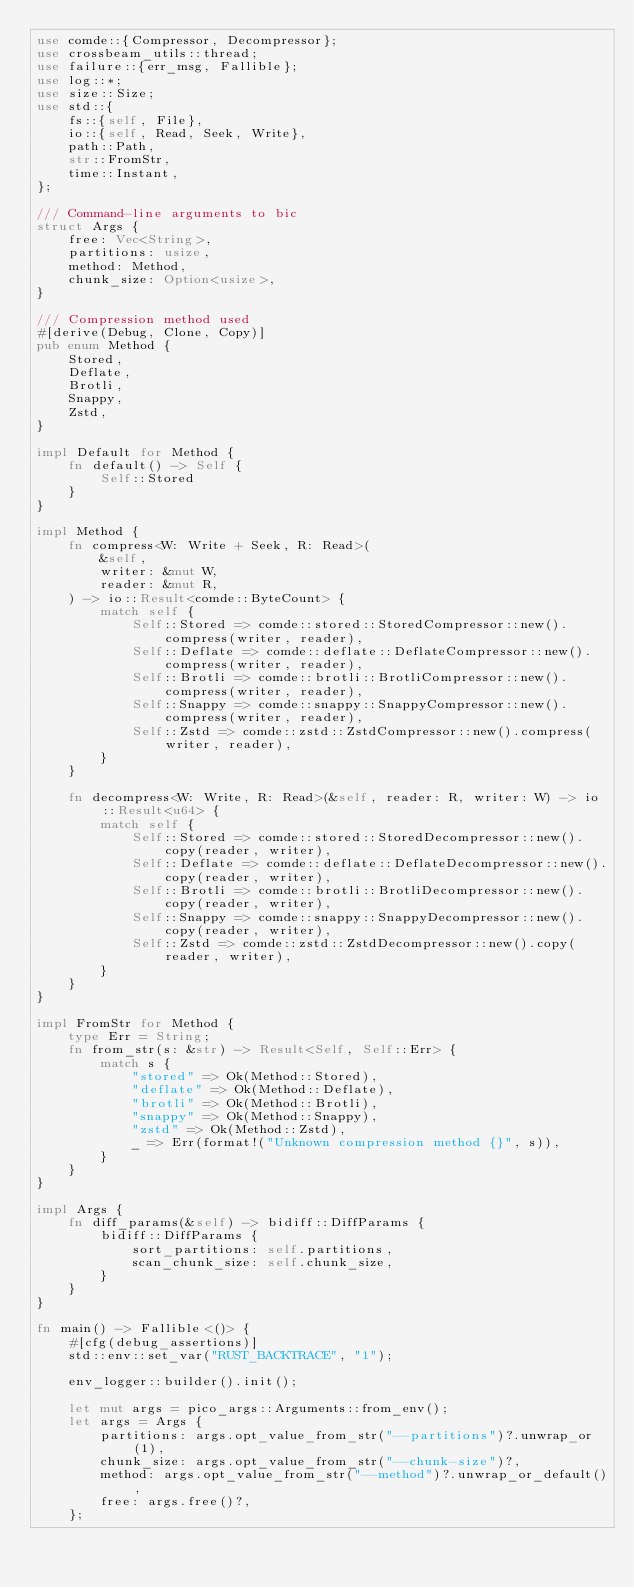<code> <loc_0><loc_0><loc_500><loc_500><_Rust_>use comde::{Compressor, Decompressor};
use crossbeam_utils::thread;
use failure::{err_msg, Fallible};
use log::*;
use size::Size;
use std::{
    fs::{self, File},
    io::{self, Read, Seek, Write},
    path::Path,
    str::FromStr,
    time::Instant,
};

/// Command-line arguments to bic
struct Args {
    free: Vec<String>,
    partitions: usize,
    method: Method,
    chunk_size: Option<usize>,
}

/// Compression method used
#[derive(Debug, Clone, Copy)]
pub enum Method {
    Stored,
    Deflate,
    Brotli,
    Snappy,
    Zstd,
}

impl Default for Method {
    fn default() -> Self {
        Self::Stored
    }
}

impl Method {
    fn compress<W: Write + Seek, R: Read>(
        &self,
        writer: &mut W,
        reader: &mut R,
    ) -> io::Result<comde::ByteCount> {
        match self {
            Self::Stored => comde::stored::StoredCompressor::new().compress(writer, reader),
            Self::Deflate => comde::deflate::DeflateCompressor::new().compress(writer, reader),
            Self::Brotli => comde::brotli::BrotliCompressor::new().compress(writer, reader),
            Self::Snappy => comde::snappy::SnappyCompressor::new().compress(writer, reader),
            Self::Zstd => comde::zstd::ZstdCompressor::new().compress(writer, reader),
        }
    }

    fn decompress<W: Write, R: Read>(&self, reader: R, writer: W) -> io::Result<u64> {
        match self {
            Self::Stored => comde::stored::StoredDecompressor::new().copy(reader, writer),
            Self::Deflate => comde::deflate::DeflateDecompressor::new().copy(reader, writer),
            Self::Brotli => comde::brotli::BrotliDecompressor::new().copy(reader, writer),
            Self::Snappy => comde::snappy::SnappyDecompressor::new().copy(reader, writer),
            Self::Zstd => comde::zstd::ZstdDecompressor::new().copy(reader, writer),
        }
    }
}

impl FromStr for Method {
    type Err = String;
    fn from_str(s: &str) -> Result<Self, Self::Err> {
        match s {
            "stored" => Ok(Method::Stored),
            "deflate" => Ok(Method::Deflate),
            "brotli" => Ok(Method::Brotli),
            "snappy" => Ok(Method::Snappy),
            "zstd" => Ok(Method::Zstd),
            _ => Err(format!("Unknown compression method {}", s)),
        }
    }
}

impl Args {
    fn diff_params(&self) -> bidiff::DiffParams {
        bidiff::DiffParams {
            sort_partitions: self.partitions,
            scan_chunk_size: self.chunk_size,
        }
    }
}

fn main() -> Fallible<()> {
    #[cfg(debug_assertions)]
    std::env::set_var("RUST_BACKTRACE", "1");

    env_logger::builder().init();

    let mut args = pico_args::Arguments::from_env();
    let args = Args {
        partitions: args.opt_value_from_str("--partitions")?.unwrap_or(1),
        chunk_size: args.opt_value_from_str("--chunk-size")?,
        method: args.opt_value_from_str("--method")?.unwrap_or_default(),
        free: args.free()?,
    };
</code> 